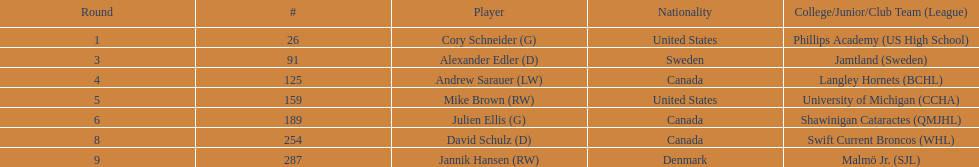How many players from canada are listed? 3. 